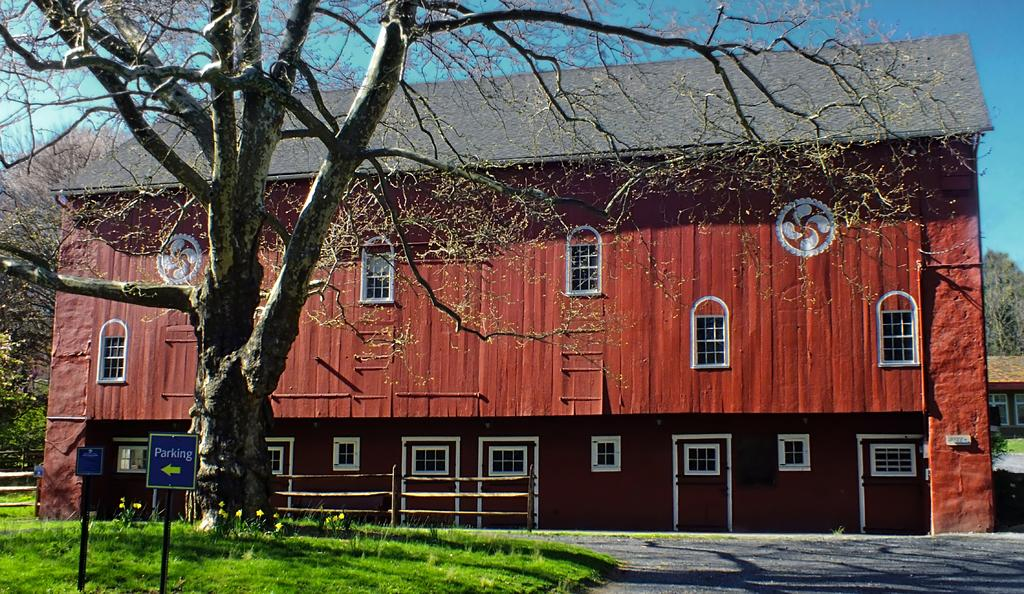What type of structures can be seen in the image? There are sign boards, buildings, and a wooden fence visible in the image. What type of vegetation is present in the image? There are trees and grass in the image. Can you hear a bear crying in the image? There is no bear or any sound present in the image, as it is a still image. 